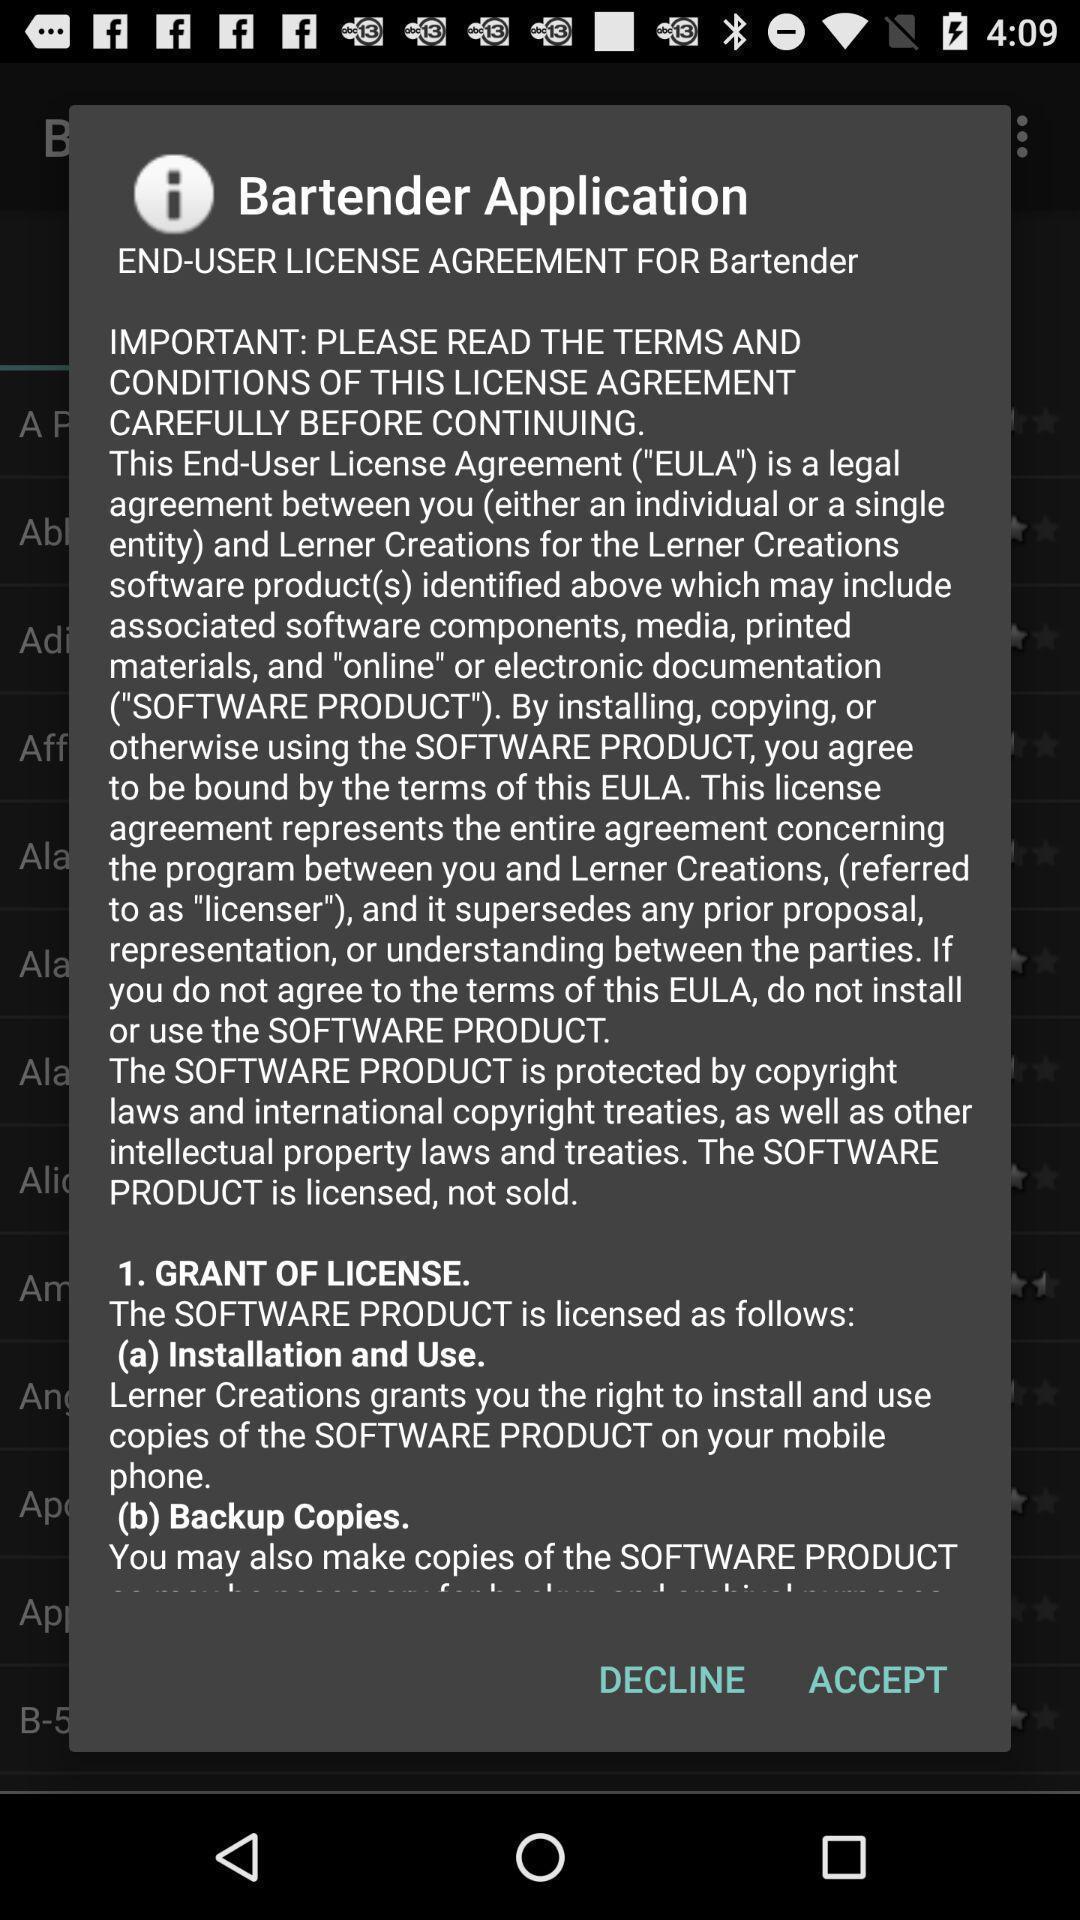Describe this image in words. Pop-up asking permission to a user license agreement. 